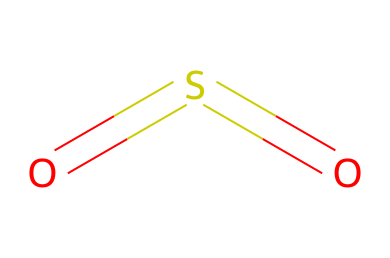What is the chemical name of this compound? The SMILES representation "O=S=O" indicates the presence of sulfur and two oxygen atoms, which corresponds to the common name for this compound.
Answer: sulfur dioxide How many oxygen atoms are in the structure? By analyzing the SMILES "O=S=O", we can count the number of 'O' characters present, which indicates there are two oxygen atoms attached to the sulfur.
Answer: two What type of bonding is present in this compound? The structure "O=S=O" reveals that there are double bonds between sulfur and each oxygen atom, indicated by the '=' symbol, which signifies strong covalent bonds.
Answer: double How many total atoms are present in the molecule? By summing up the atoms represented in the SMILES, we have one sulfur atom and two oxygen atoms, leading to a total of three atoms in the molecule.
Answer: three What is the hybridization state of the sulfur atom? The structure "O=S=O" indicates that the sulfur atom forms two double bonds, which leads to a sp hybridization, as it has a planar arrangement with trigonal symmetry.
Answer: sp Is this compound an acid or a base? Sulfur dioxide can form sulfurous acid when dissolved in water and is generally considered to have acidic properties, as it can donate protons in reactions.
Answer: acid 